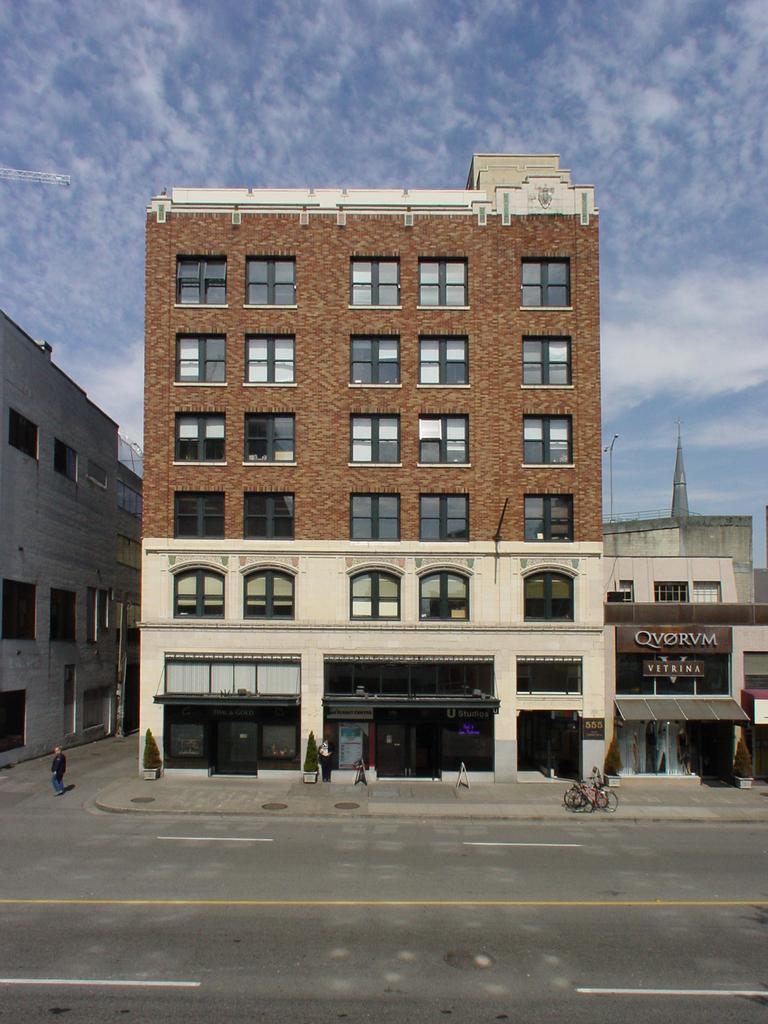Describe this image in one or two sentences. In this image I see the buildings and I see the road and I can also see the cycles, few people and few words written over here. In the background I see the sky and I see the bushes. 